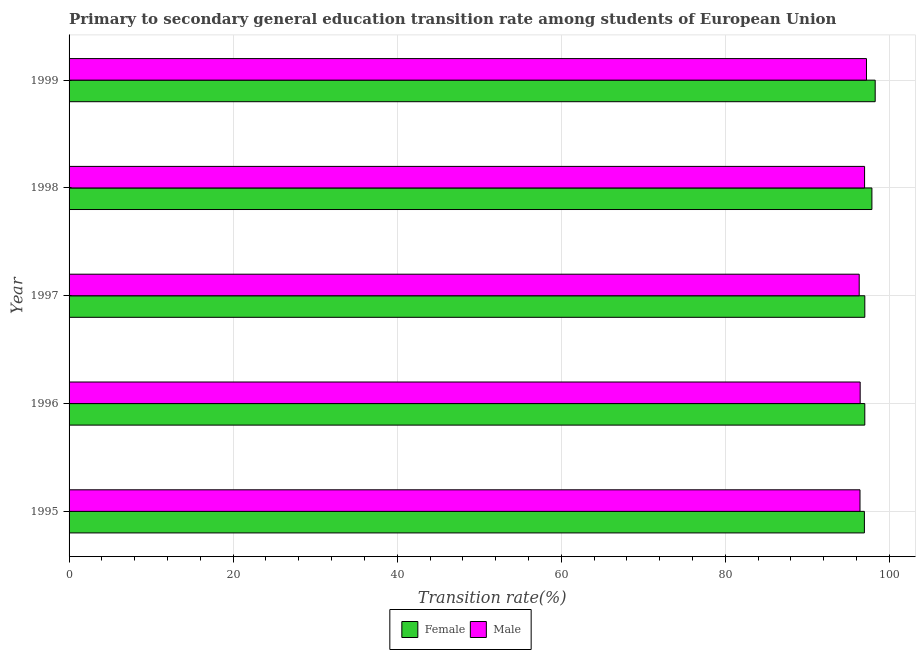How many different coloured bars are there?
Make the answer very short. 2. How many groups of bars are there?
Offer a very short reply. 5. Are the number of bars on each tick of the Y-axis equal?
Your answer should be very brief. Yes. In how many cases, is the number of bars for a given year not equal to the number of legend labels?
Ensure brevity in your answer.  0. What is the transition rate among female students in 1995?
Keep it short and to the point. 96.95. Across all years, what is the maximum transition rate among male students?
Provide a short and direct response. 97.21. Across all years, what is the minimum transition rate among male students?
Keep it short and to the point. 96.32. In which year was the transition rate among female students minimum?
Ensure brevity in your answer.  1995. What is the total transition rate among male students in the graph?
Make the answer very short. 483.36. What is the difference between the transition rate among male students in 1995 and that in 1997?
Your response must be concise. 0.1. What is the difference between the transition rate among female students in 1998 and the transition rate among male students in 1999?
Your response must be concise. 0.66. What is the average transition rate among male students per year?
Provide a short and direct response. 96.67. In the year 1999, what is the difference between the transition rate among female students and transition rate among male students?
Offer a terse response. 1.06. Is the difference between the transition rate among female students in 1996 and 1999 greater than the difference between the transition rate among male students in 1996 and 1999?
Offer a terse response. No. What is the difference between the highest and the second highest transition rate among male students?
Provide a succinct answer. 0.23. What is the difference between the highest and the lowest transition rate among male students?
Provide a short and direct response. 0.89. Is the sum of the transition rate among female students in 1995 and 1998 greater than the maximum transition rate among male students across all years?
Your response must be concise. Yes. What does the 2nd bar from the bottom in 1995 represents?
Your response must be concise. Male. Are the values on the major ticks of X-axis written in scientific E-notation?
Ensure brevity in your answer.  No. Where does the legend appear in the graph?
Provide a succinct answer. Bottom center. How many legend labels are there?
Give a very brief answer. 2. What is the title of the graph?
Your answer should be very brief. Primary to secondary general education transition rate among students of European Union. What is the label or title of the X-axis?
Keep it short and to the point. Transition rate(%). What is the Transition rate(%) of Female in 1995?
Ensure brevity in your answer.  96.95. What is the Transition rate(%) of Male in 1995?
Provide a succinct answer. 96.42. What is the Transition rate(%) in Female in 1996?
Keep it short and to the point. 97. What is the Transition rate(%) of Male in 1996?
Offer a terse response. 96.44. What is the Transition rate(%) of Female in 1997?
Your answer should be compact. 97. What is the Transition rate(%) in Male in 1997?
Offer a terse response. 96.32. What is the Transition rate(%) of Female in 1998?
Ensure brevity in your answer.  97.87. What is the Transition rate(%) of Male in 1998?
Keep it short and to the point. 96.98. What is the Transition rate(%) of Female in 1999?
Ensure brevity in your answer.  98.27. What is the Transition rate(%) in Male in 1999?
Offer a terse response. 97.21. Across all years, what is the maximum Transition rate(%) of Female?
Your answer should be very brief. 98.27. Across all years, what is the maximum Transition rate(%) of Male?
Your answer should be compact. 97.21. Across all years, what is the minimum Transition rate(%) of Female?
Provide a succinct answer. 96.95. Across all years, what is the minimum Transition rate(%) in Male?
Your answer should be very brief. 96.32. What is the total Transition rate(%) of Female in the graph?
Give a very brief answer. 487.1. What is the total Transition rate(%) of Male in the graph?
Ensure brevity in your answer.  483.36. What is the difference between the Transition rate(%) in Female in 1995 and that in 1996?
Offer a very short reply. -0.05. What is the difference between the Transition rate(%) in Male in 1995 and that in 1996?
Your answer should be very brief. -0.02. What is the difference between the Transition rate(%) in Male in 1995 and that in 1997?
Your answer should be very brief. 0.1. What is the difference between the Transition rate(%) in Female in 1995 and that in 1998?
Give a very brief answer. -0.92. What is the difference between the Transition rate(%) in Male in 1995 and that in 1998?
Provide a succinct answer. -0.56. What is the difference between the Transition rate(%) in Female in 1995 and that in 1999?
Make the answer very short. -1.32. What is the difference between the Transition rate(%) of Male in 1995 and that in 1999?
Provide a succinct answer. -0.79. What is the difference between the Transition rate(%) in Female in 1996 and that in 1997?
Your answer should be very brief. -0. What is the difference between the Transition rate(%) in Male in 1996 and that in 1997?
Provide a succinct answer. 0.12. What is the difference between the Transition rate(%) in Female in 1996 and that in 1998?
Give a very brief answer. -0.87. What is the difference between the Transition rate(%) in Male in 1996 and that in 1998?
Offer a terse response. -0.54. What is the difference between the Transition rate(%) of Female in 1996 and that in 1999?
Make the answer very short. -1.27. What is the difference between the Transition rate(%) of Male in 1996 and that in 1999?
Make the answer very short. -0.77. What is the difference between the Transition rate(%) in Female in 1997 and that in 1998?
Give a very brief answer. -0.87. What is the difference between the Transition rate(%) in Male in 1997 and that in 1998?
Make the answer very short. -0.66. What is the difference between the Transition rate(%) of Female in 1997 and that in 1999?
Keep it short and to the point. -1.27. What is the difference between the Transition rate(%) in Male in 1997 and that in 1999?
Offer a very short reply. -0.89. What is the difference between the Transition rate(%) in Female in 1998 and that in 1999?
Make the answer very short. -0.4. What is the difference between the Transition rate(%) of Male in 1998 and that in 1999?
Give a very brief answer. -0.23. What is the difference between the Transition rate(%) of Female in 1995 and the Transition rate(%) of Male in 1996?
Give a very brief answer. 0.51. What is the difference between the Transition rate(%) of Female in 1995 and the Transition rate(%) of Male in 1997?
Give a very brief answer. 0.63. What is the difference between the Transition rate(%) in Female in 1995 and the Transition rate(%) in Male in 1998?
Your answer should be compact. -0.02. What is the difference between the Transition rate(%) of Female in 1995 and the Transition rate(%) of Male in 1999?
Provide a succinct answer. -0.25. What is the difference between the Transition rate(%) in Female in 1996 and the Transition rate(%) in Male in 1997?
Offer a very short reply. 0.68. What is the difference between the Transition rate(%) of Female in 1996 and the Transition rate(%) of Male in 1998?
Make the answer very short. 0.03. What is the difference between the Transition rate(%) in Female in 1996 and the Transition rate(%) in Male in 1999?
Provide a succinct answer. -0.21. What is the difference between the Transition rate(%) in Female in 1997 and the Transition rate(%) in Male in 1998?
Provide a succinct answer. 0.03. What is the difference between the Transition rate(%) in Female in 1997 and the Transition rate(%) in Male in 1999?
Make the answer very short. -0.2. What is the difference between the Transition rate(%) in Female in 1998 and the Transition rate(%) in Male in 1999?
Your response must be concise. 0.66. What is the average Transition rate(%) of Female per year?
Offer a very short reply. 97.42. What is the average Transition rate(%) of Male per year?
Provide a succinct answer. 96.67. In the year 1995, what is the difference between the Transition rate(%) in Female and Transition rate(%) in Male?
Give a very brief answer. 0.54. In the year 1996, what is the difference between the Transition rate(%) in Female and Transition rate(%) in Male?
Offer a terse response. 0.56. In the year 1997, what is the difference between the Transition rate(%) in Female and Transition rate(%) in Male?
Offer a terse response. 0.68. In the year 1998, what is the difference between the Transition rate(%) of Female and Transition rate(%) of Male?
Offer a very short reply. 0.89. In the year 1999, what is the difference between the Transition rate(%) in Female and Transition rate(%) in Male?
Give a very brief answer. 1.06. What is the ratio of the Transition rate(%) of Female in 1995 to that in 1997?
Offer a very short reply. 1. What is the ratio of the Transition rate(%) of Female in 1995 to that in 1998?
Your answer should be compact. 0.99. What is the ratio of the Transition rate(%) of Female in 1995 to that in 1999?
Keep it short and to the point. 0.99. What is the ratio of the Transition rate(%) of Male in 1995 to that in 1999?
Your answer should be very brief. 0.99. What is the ratio of the Transition rate(%) of Female in 1996 to that in 1997?
Offer a very short reply. 1. What is the ratio of the Transition rate(%) in Male in 1996 to that in 1997?
Offer a very short reply. 1. What is the ratio of the Transition rate(%) of Male in 1996 to that in 1998?
Keep it short and to the point. 0.99. What is the ratio of the Transition rate(%) of Female in 1996 to that in 1999?
Provide a short and direct response. 0.99. What is the ratio of the Transition rate(%) of Male in 1996 to that in 1999?
Give a very brief answer. 0.99. What is the ratio of the Transition rate(%) in Female in 1997 to that in 1998?
Ensure brevity in your answer.  0.99. What is the ratio of the Transition rate(%) of Male in 1997 to that in 1998?
Ensure brevity in your answer.  0.99. What is the ratio of the Transition rate(%) in Female in 1997 to that in 1999?
Give a very brief answer. 0.99. What is the ratio of the Transition rate(%) in Male in 1997 to that in 1999?
Offer a terse response. 0.99. What is the ratio of the Transition rate(%) in Male in 1998 to that in 1999?
Make the answer very short. 1. What is the difference between the highest and the second highest Transition rate(%) of Female?
Offer a terse response. 0.4. What is the difference between the highest and the second highest Transition rate(%) in Male?
Provide a succinct answer. 0.23. What is the difference between the highest and the lowest Transition rate(%) of Female?
Offer a very short reply. 1.32. What is the difference between the highest and the lowest Transition rate(%) in Male?
Your response must be concise. 0.89. 